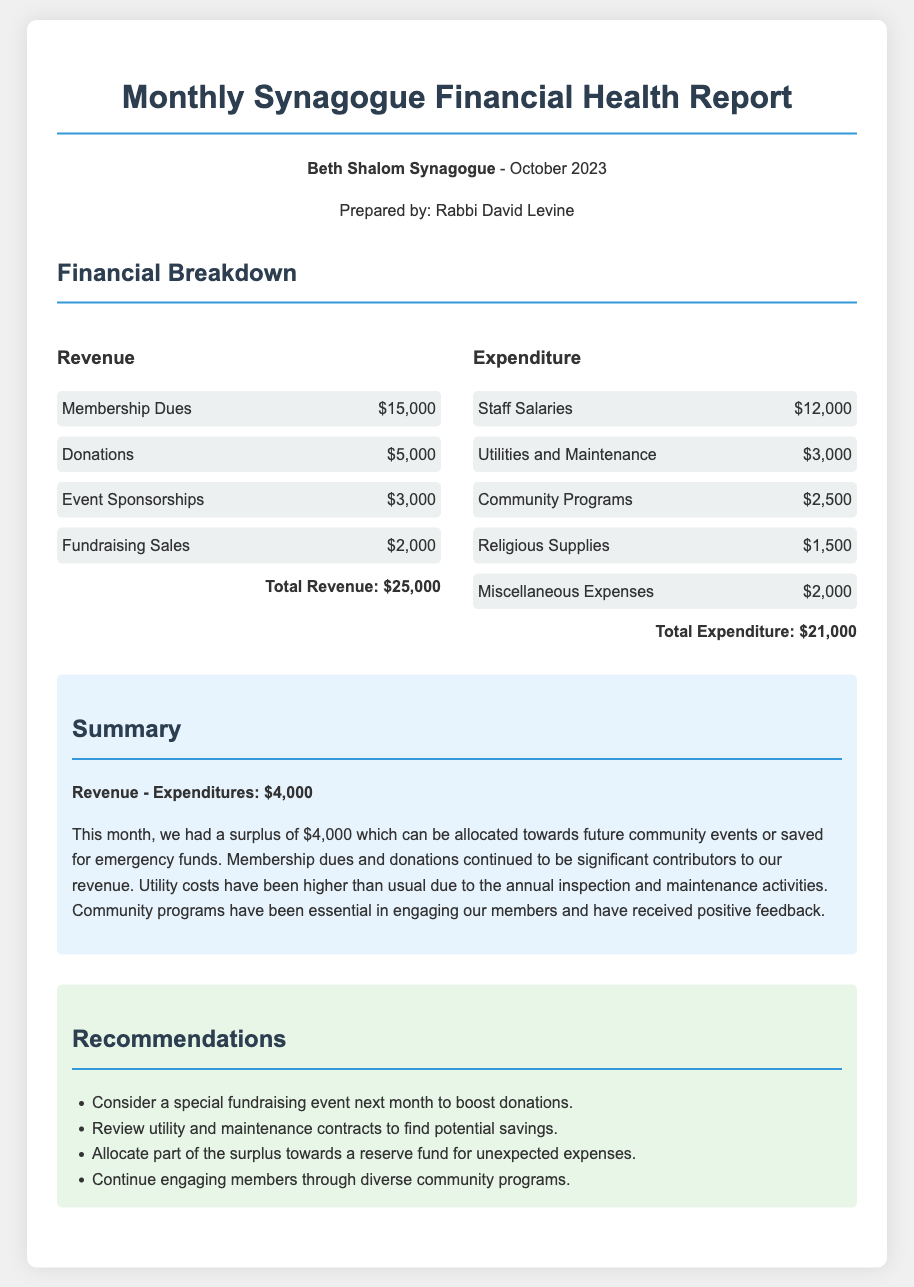what is the total revenue? The total revenue is the sum of all revenue sources in the document: Membership Dues ($15,000) + Donations ($5,000) + Event Sponsorships ($3,000) + Fundraising Sales ($2,000) = $25,000.
Answer: $25,000 what is the total expenditure? The total expenditure is the sum of all expenditure categories in the document: Staff Salaries ($12,000) + Utilities and Maintenance ($3,000) + Community Programs ($2,500) + Religious Supplies ($1,500) + Miscellaneous Expenses ($2,000) = $21,000.
Answer: $21,000 what is the surplus for October 2023? The surplus is calculated by subtracting the total expenditure from the total revenue: $25,000 - $21,000 = $4,000.
Answer: $4,000 who prepared the report? The report was prepared by Rabbi David Levine, as indicated in the heading of the document.
Answer: Rabbi David Levine which category had the highest revenue? Membership Dues had the highest revenue, with an amount of $15,000.
Answer: Membership Dues what was the main expenditure in October 2023? The main expenditure was Staff Salaries, totaling $12,000.
Answer: Staff Salaries what is one recommended action for next month? One recommended action is to consider a special fundraising event next month to boost donations.
Answer: Special fundraising event which utility costs have increased? Utilities and Maintenance costs have increased due to the annual inspection and maintenance activities.
Answer: Utilities and Maintenance how much is allocated for Community Programs? The expenditure allocated for Community Programs is $2,500.
Answer: $2,500 